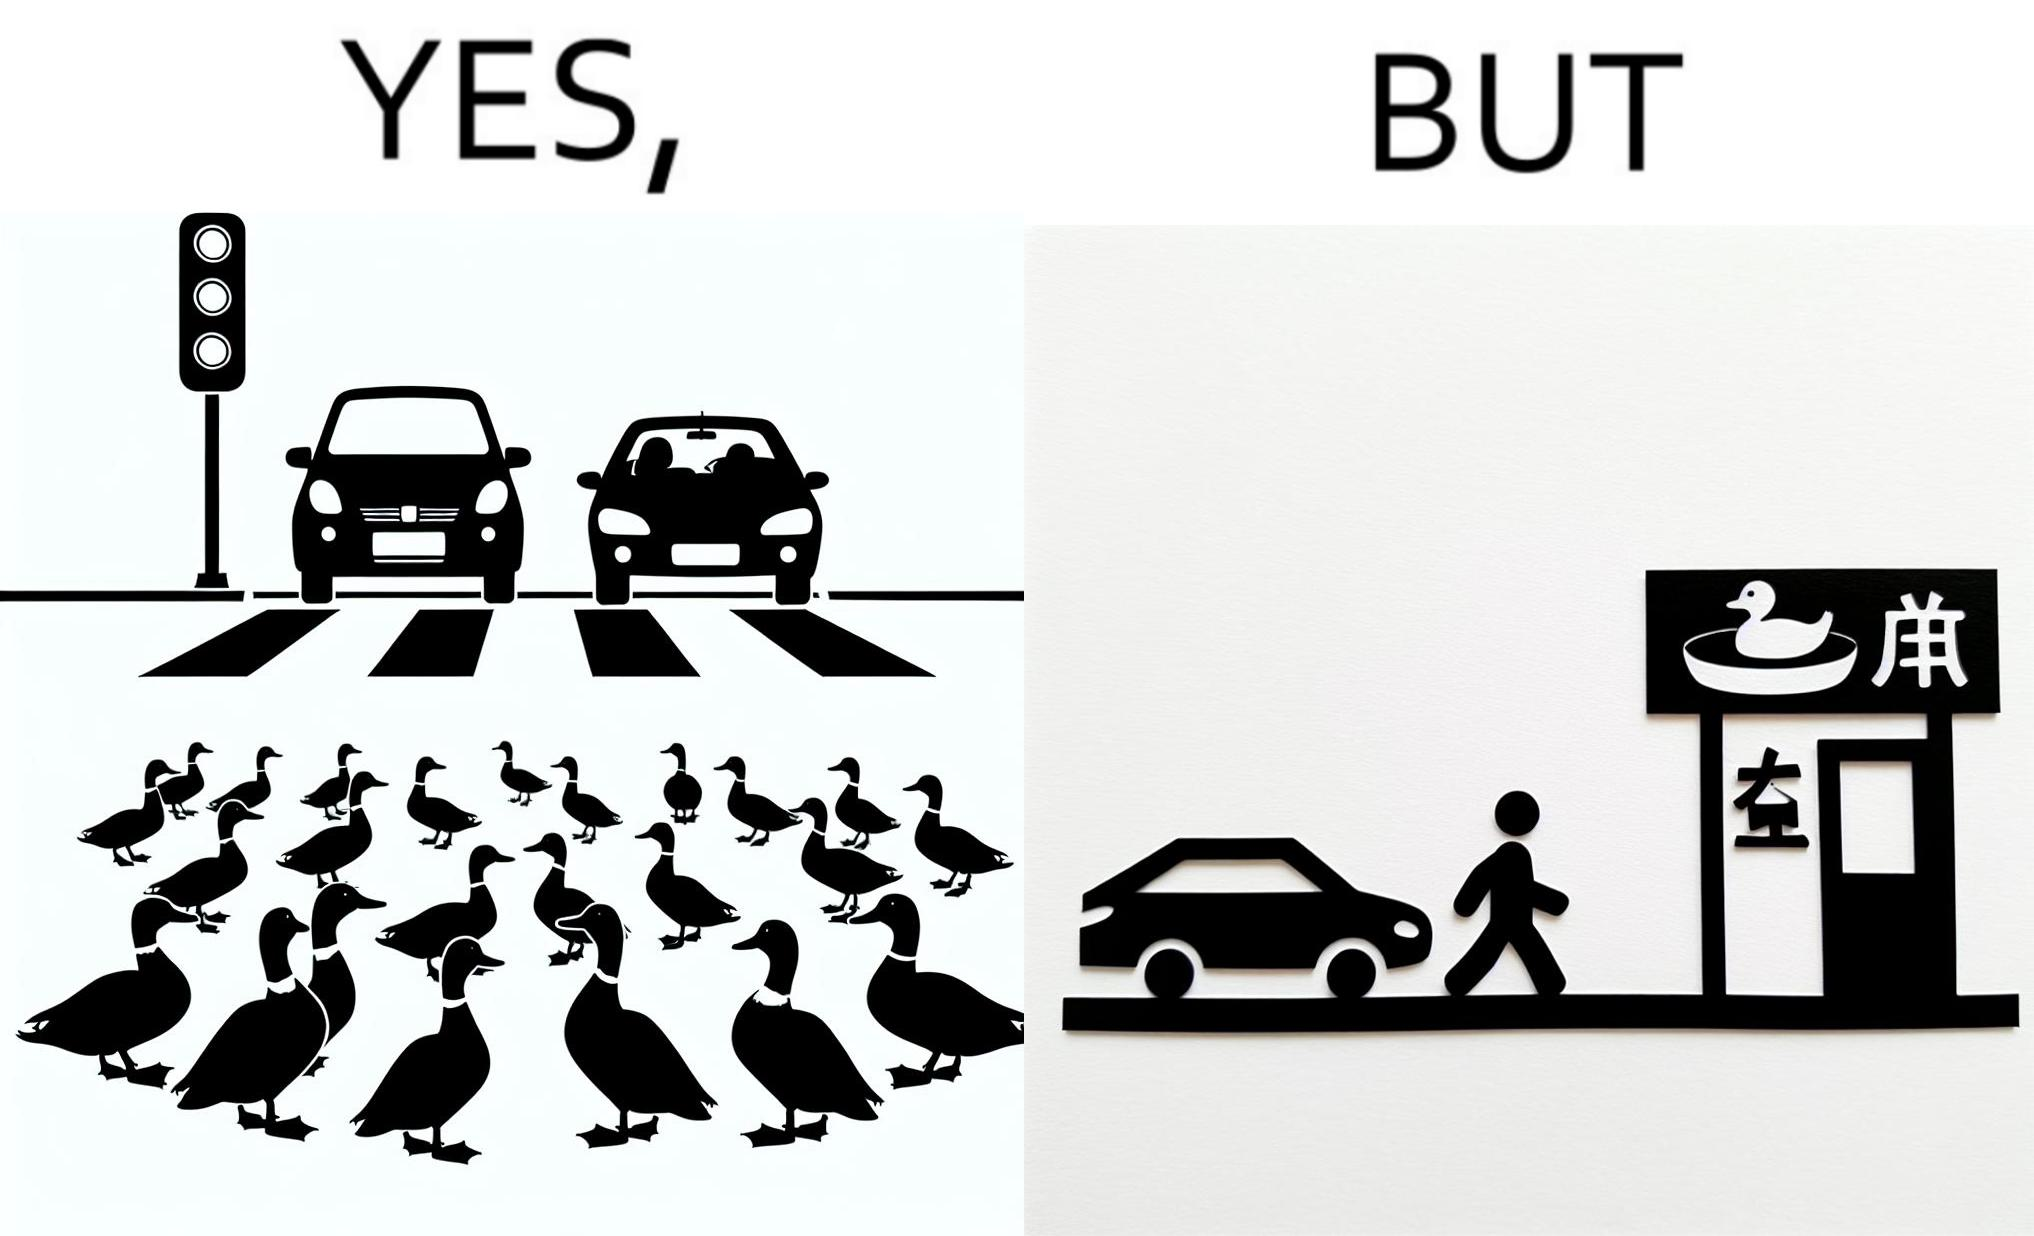Does this image contain satire or humor? Yes, this image is satirical. 